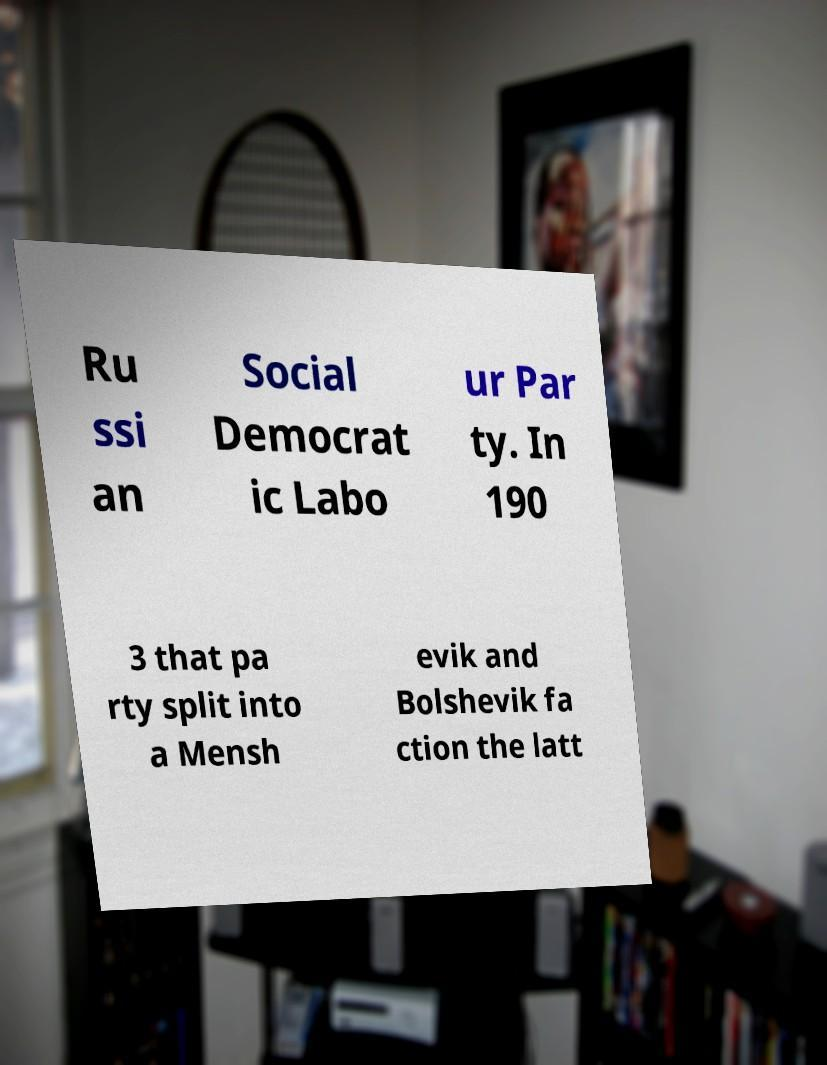What messages or text are displayed in this image? I need them in a readable, typed format. Ru ssi an Social Democrat ic Labo ur Par ty. In 190 3 that pa rty split into a Mensh evik and Bolshevik fa ction the latt 